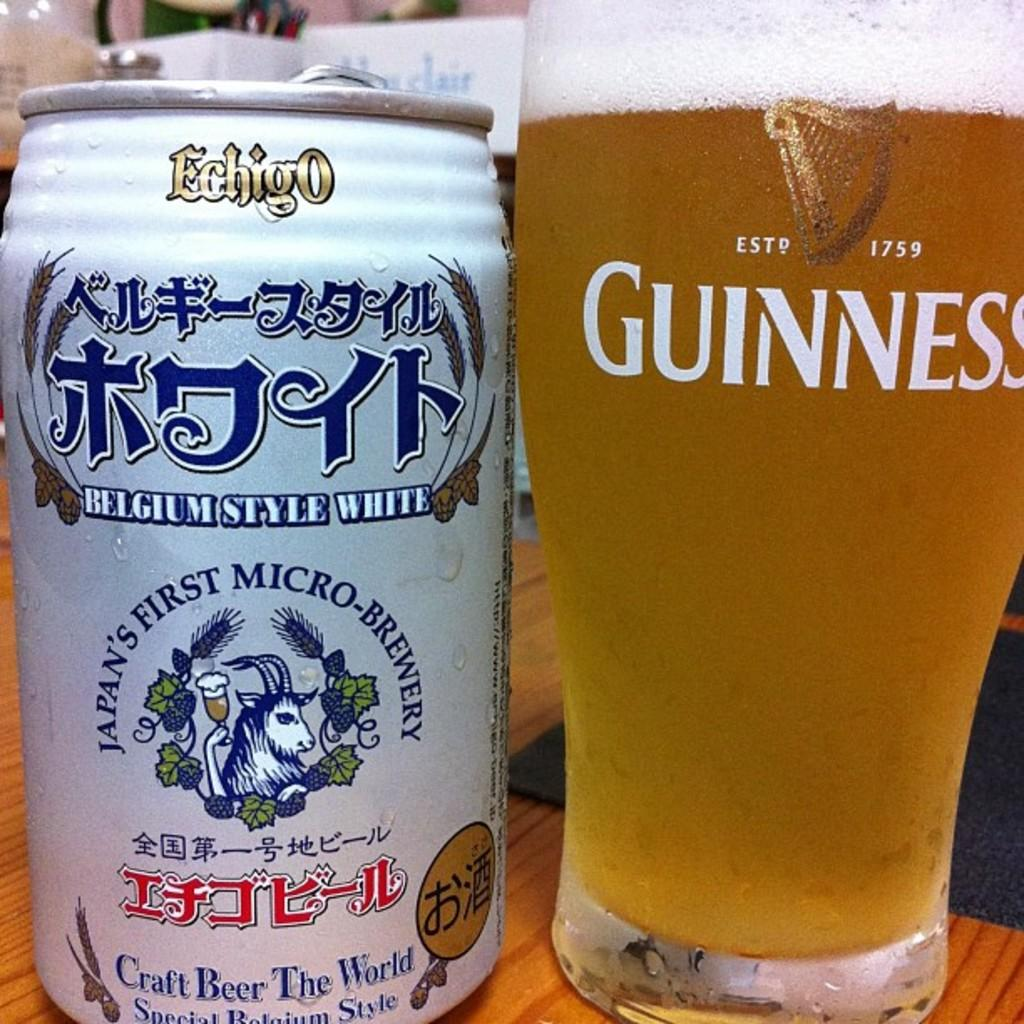<image>
Create a compact narrative representing the image presented. A guinness beer glass beside a japanese craft beer can. 